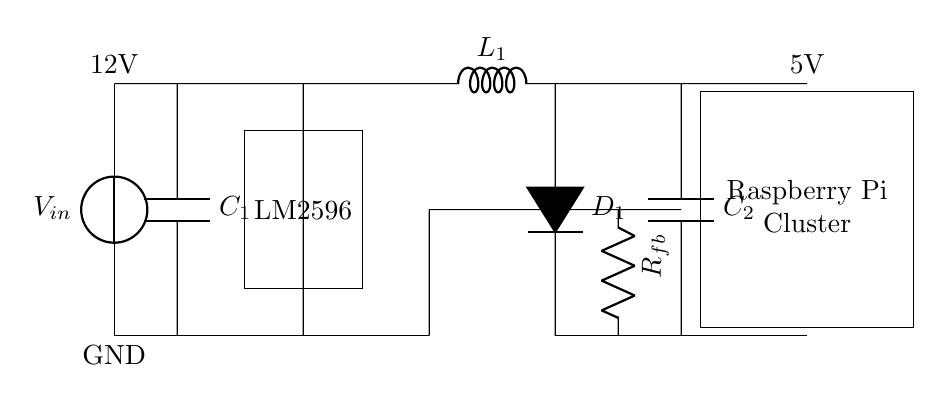What is the input voltage of this circuit? The input voltage, labeled as V_in, is indicated at the entry point of the circuit diagram, and it is shown to be 12V.
Answer: 12V What type of voltage regulator is used in this circuit? The circuit diagram specifies the component labeled LM2596, which is a common type of buck voltage regulator used to step down voltage.
Answer: LM2596 How many capacitors are present in the circuit? The diagram clearly shows two capacitors, C1 and C2, which are labeled along the vertical branch of the circuit.
Answer: 2 What is the output voltage provided to the Raspberry Pi cluster? The output voltage is indicated in the diagram as being 5V, shown at the output connection leading to the Raspberry Pi cluster.
Answer: 5V What is the purpose of the feedback resistor in this circuit? The feedback resistor, labeled R_fb, is typically used to regulate the output voltage by providing feedback to the voltage regulator, helping maintain stability and accuracy.
Answer: Regulate How does the inductor contribute to the voltage regulation process in this circuit? The inductor, L1, works by storing energy when the current flows through it and releasing it when the current decreases, smoothing out the output voltage and reducing ripple.
Answer: Smooth voltage What is the role of the diode in this circuit? The diode D1 is used to prevent backflow of current, ensuring that the electric current flows in the correct direction to protect the components in the circuit.
Answer: Prevent backflow 